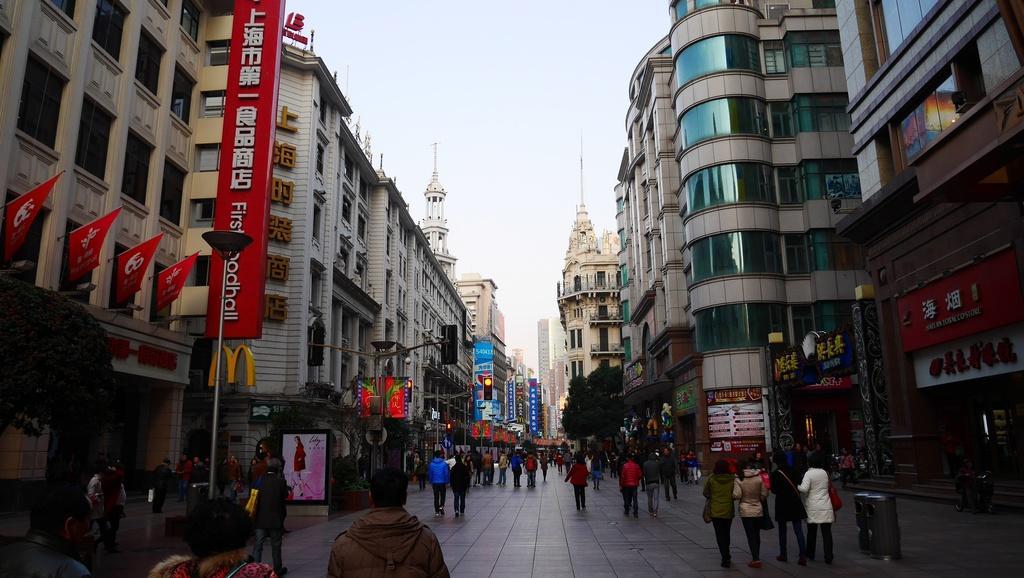Could you give a brief overview of what you see in this image? There are people, posters, stalls and buildings on both the sides of the image and there is sky in the background area. 